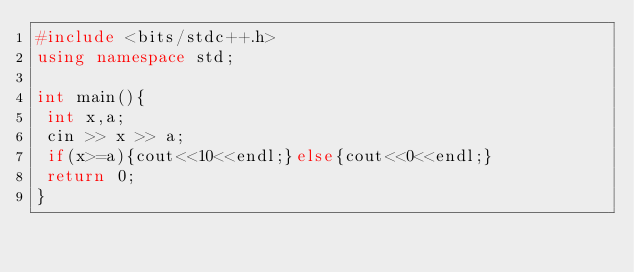<code> <loc_0><loc_0><loc_500><loc_500><_C++_>#include <bits/stdc++.h>
using namespace std;

int main(){
 int x,a;
 cin >> x >> a;
 if(x>=a){cout<<10<<endl;}else{cout<<0<<endl;}
 return 0;
}</code> 